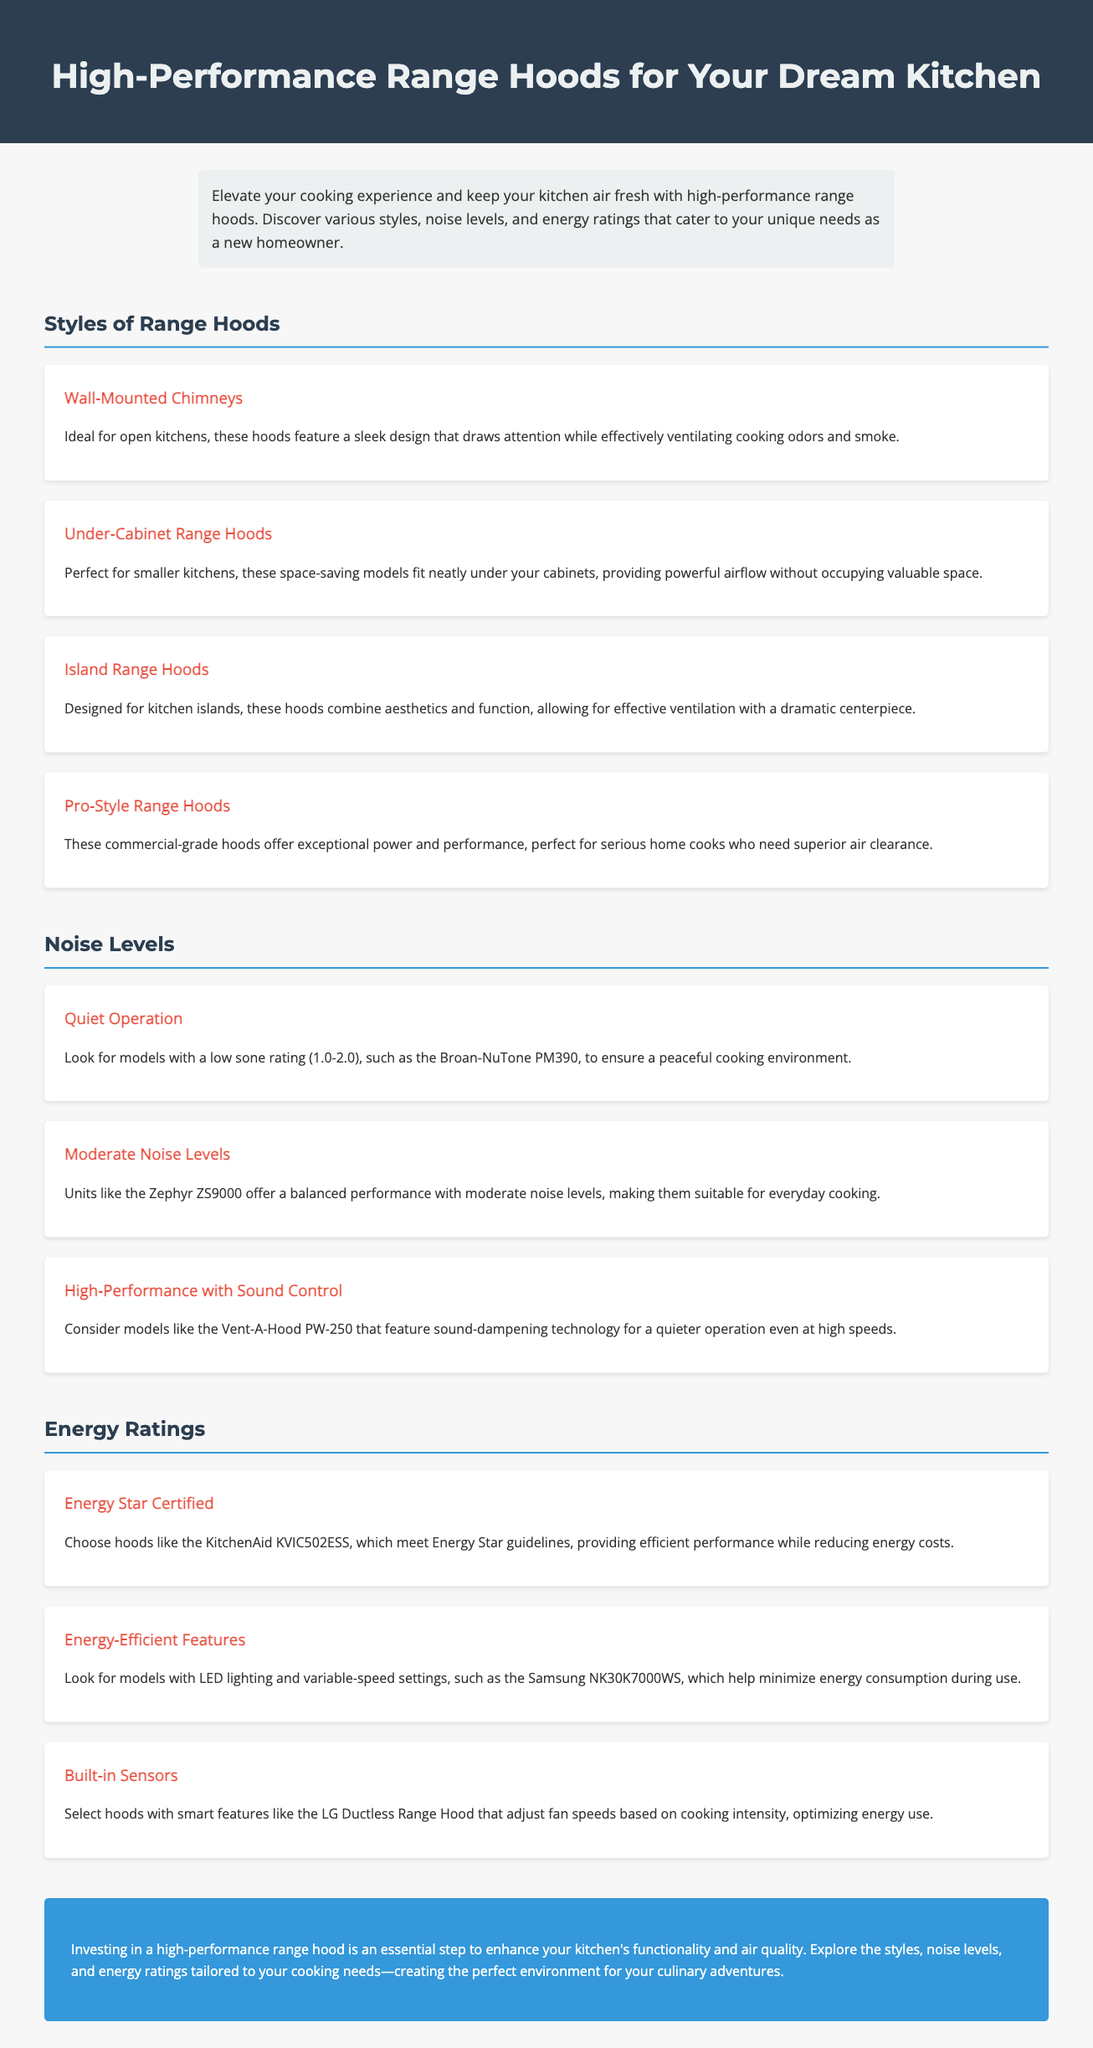What are the styles of range hoods mentioned? The document lists several styles: Wall-Mounted Chimneys, Under-Cabinet Range Hoods, Island Range Hoods, and Pro-Style Range Hoods.
Answer: Wall-Mounted Chimneys, Under-Cabinet Range Hoods, Island Range Hoods, Pro-Style Range Hoods What noise level corresponds to a quiet operation? The document specifies a low sone rating of 1.0-2.0 for quiet operation.
Answer: 1.0-2.0 Which range hood features sound-dampening technology? The document mentions the Vent-A-Hood PW-250 as a model that features sound-dampening technology.
Answer: Vent-A-Hood PW-250 What energy rating do the KitchenAid KVIC502ESS range hood meet? The KitchenAid KVIC502ESS range hood is stated to meet Energy Star guidelines.
Answer: Energy Star What is a feature of the Samsung NK30K7000WS model? The document describes the Samsung NK30K7000WS as having LED lighting and variable-speed settings.
Answer: LED lighting and variable-speed settings What type of range hood is ideal for smaller kitchens? The document indicates that Under-Cabinet Range Hoods are perfect for smaller kitchens.
Answer: Under-Cabinet Range Hoods Which type of range hood is designed for kitchen islands? The document states that Island Range Hoods are designed for kitchen islands.
Answer: Island Range Hoods What should you look for to minimize energy consumption during use? The document suggests looking for models with features like LED lighting and variable-speed settings.
Answer: LED lighting and variable-speed settings What is the conclusion about investing in range hoods? The document concludes that investing in a high-performance range hood enhances kitchen functionality and air quality.
Answer: Enhances kitchen functionality and air quality 